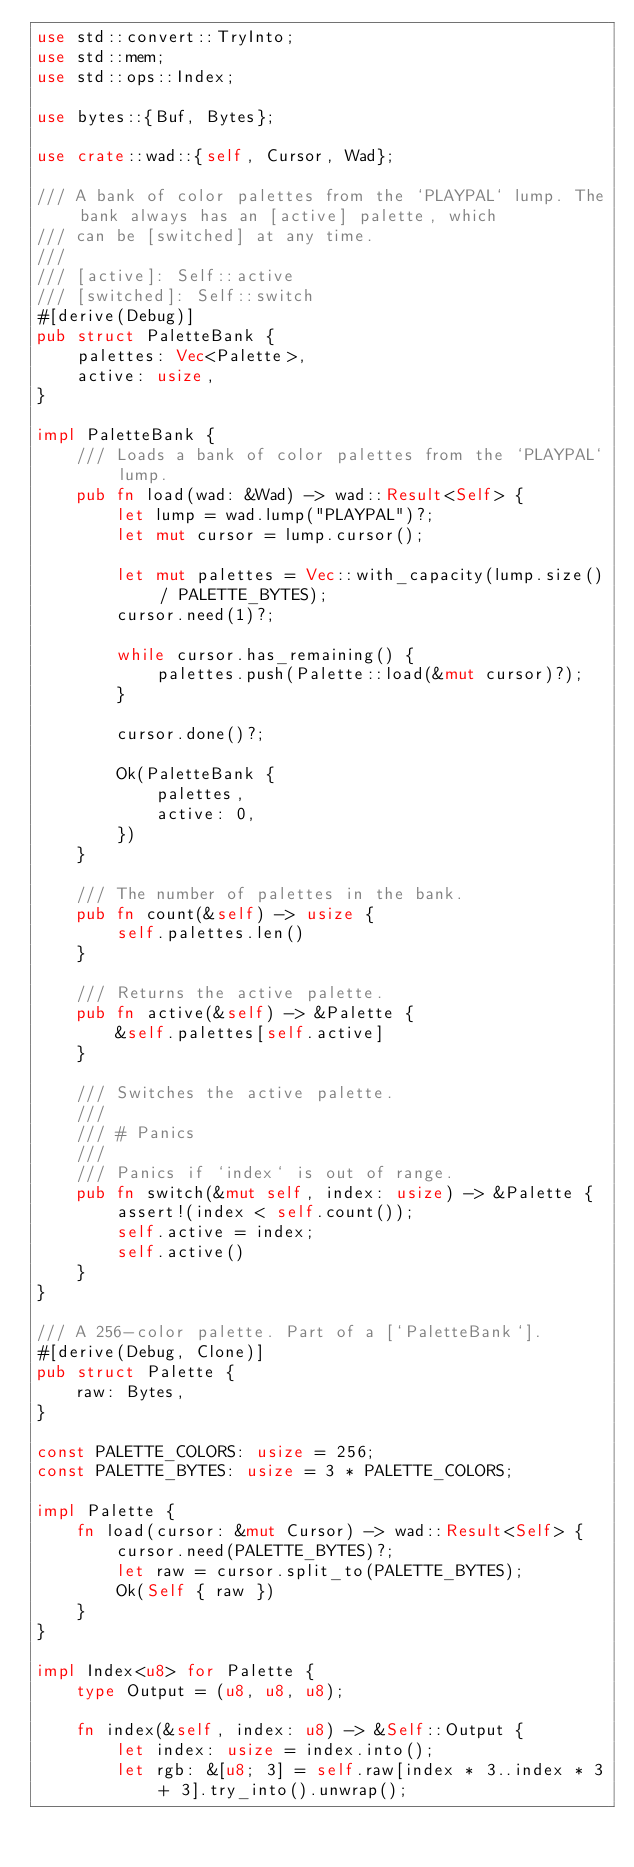<code> <loc_0><loc_0><loc_500><loc_500><_Rust_>use std::convert::TryInto;
use std::mem;
use std::ops::Index;

use bytes::{Buf, Bytes};

use crate::wad::{self, Cursor, Wad};

/// A bank of color palettes from the `PLAYPAL` lump. The bank always has an [active] palette, which
/// can be [switched] at any time.
///
/// [active]: Self::active
/// [switched]: Self::switch
#[derive(Debug)]
pub struct PaletteBank {
    palettes: Vec<Palette>,
    active: usize,
}

impl PaletteBank {
    /// Loads a bank of color palettes from the `PLAYPAL` lump.
    pub fn load(wad: &Wad) -> wad::Result<Self> {
        let lump = wad.lump("PLAYPAL")?;
        let mut cursor = lump.cursor();

        let mut palettes = Vec::with_capacity(lump.size() / PALETTE_BYTES);
        cursor.need(1)?;

        while cursor.has_remaining() {
            palettes.push(Palette::load(&mut cursor)?);
        }

        cursor.done()?;

        Ok(PaletteBank {
            palettes,
            active: 0,
        })
    }

    /// The number of palettes in the bank.
    pub fn count(&self) -> usize {
        self.palettes.len()
    }

    /// Returns the active palette.
    pub fn active(&self) -> &Palette {
        &self.palettes[self.active]
    }

    /// Switches the active palette.
    ///
    /// # Panics
    ///
    /// Panics if `index` is out of range.
    pub fn switch(&mut self, index: usize) -> &Palette {
        assert!(index < self.count());
        self.active = index;
        self.active()
    }
}

/// A 256-color palette. Part of a [`PaletteBank`].
#[derive(Debug, Clone)]
pub struct Palette {
    raw: Bytes,
}

const PALETTE_COLORS: usize = 256;
const PALETTE_BYTES: usize = 3 * PALETTE_COLORS;

impl Palette {
    fn load(cursor: &mut Cursor) -> wad::Result<Self> {
        cursor.need(PALETTE_BYTES)?;
        let raw = cursor.split_to(PALETTE_BYTES);
        Ok(Self { raw })
    }
}

impl Index<u8> for Palette {
    type Output = (u8, u8, u8);

    fn index(&self, index: u8) -> &Self::Output {
        let index: usize = index.into();
        let rgb: &[u8; 3] = self.raw[index * 3..index * 3 + 3].try_into().unwrap();</code> 